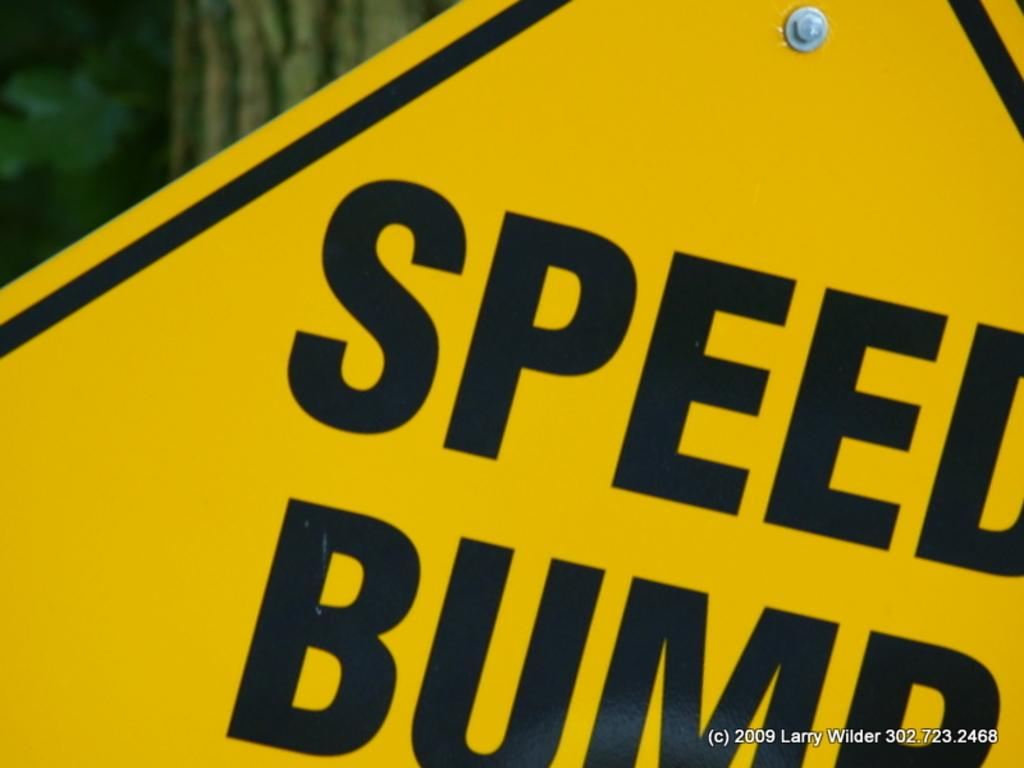Provide a one-sentence caption for the provided image. A yellow street sign for a Speed Bump. 